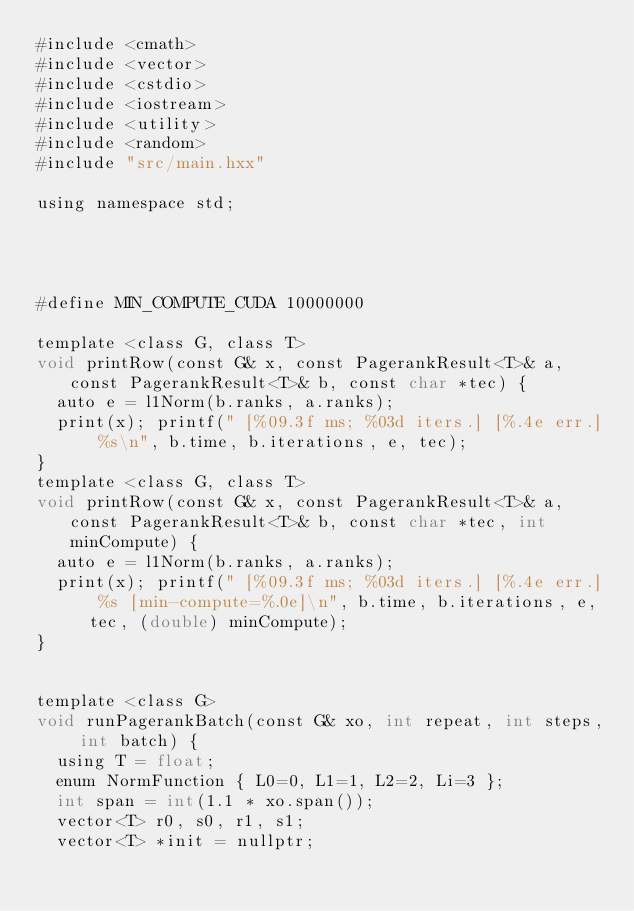<code> <loc_0><loc_0><loc_500><loc_500><_Cuda_>#include <cmath>
#include <vector>
#include <cstdio>
#include <iostream>
#include <utility>
#include <random>
#include "src/main.hxx"

using namespace std;




#define MIN_COMPUTE_CUDA 10000000

template <class G, class T>
void printRow(const G& x, const PagerankResult<T>& a, const PagerankResult<T>& b, const char *tec) {
  auto e = l1Norm(b.ranks, a.ranks);
  print(x); printf(" [%09.3f ms; %03d iters.] [%.4e err.] %s\n", b.time, b.iterations, e, tec);
}
template <class G, class T>
void printRow(const G& x, const PagerankResult<T>& a, const PagerankResult<T>& b, const char *tec, int minCompute) {
  auto e = l1Norm(b.ranks, a.ranks);
  print(x); printf(" [%09.3f ms; %03d iters.] [%.4e err.] %s [min-compute=%.0e]\n", b.time, b.iterations, e, tec, (double) minCompute);
}


template <class G>
void runPagerankBatch(const G& xo, int repeat, int steps, int batch) {
  using T = float;
  enum NormFunction { L0=0, L1=1, L2=2, Li=3 };
  int span = int(1.1 * xo.span());
  vector<T> r0, s0, r1, s1;
  vector<T> *init = nullptr;</code> 